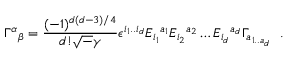Convert formula to latex. <formula><loc_0><loc_0><loc_500><loc_500>\Gamma ^ { \alpha _ { \beta } = \frac { ( - 1 ) ^ { d ( d - 3 ) / 4 } } { d ! { \sqrt { - } \gamma } } \epsilon ^ { i _ { 1 } . . i _ { d } } E _ { i _ { 1 } ^ { a _ { 1 } } E _ { i _ { 2 } ^ { a _ { 2 } } \dots E _ { i _ { d } ^ { a _ { d } } \Gamma _ { a _ { 1 . . a { _ { d } } } } .</formula> 